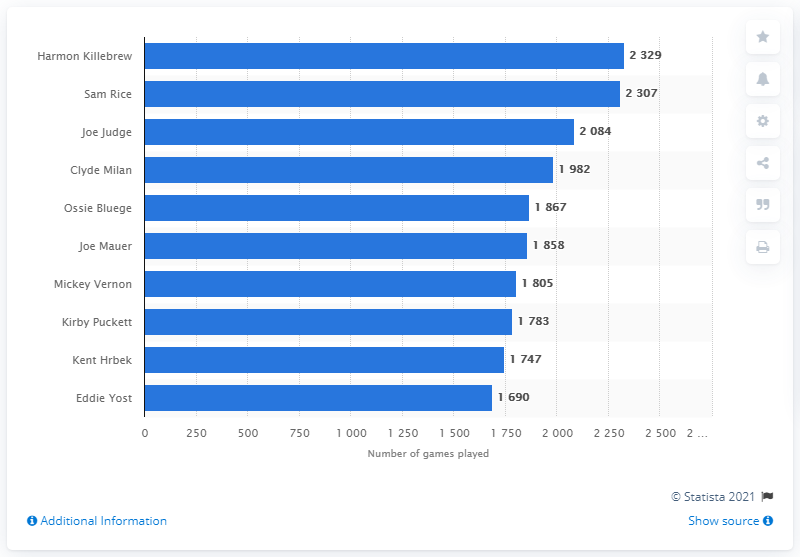Indicate a few pertinent items in this graphic. Harmon Killebrew has played the most games in the history of the Minnesota Twins franchise. 